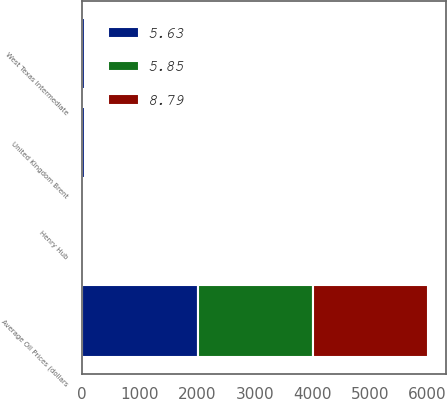Convert chart. <chart><loc_0><loc_0><loc_500><loc_500><stacked_bar_chart><ecel><fcel>Average Oil Prices (dollars<fcel>West Texas Intermediate<fcel>United Kingdom Brent<fcel>Henry Hub<nl><fcel>5.63<fcel>2005<fcel>56.3<fcel>54.45<fcel>8.79<nl><fcel>8.79<fcel>2004<fcel>41.31<fcel>38.14<fcel>5.85<nl><fcel>5.85<fcel>2003<fcel>31.14<fcel>28.78<fcel>5.63<nl></chart> 